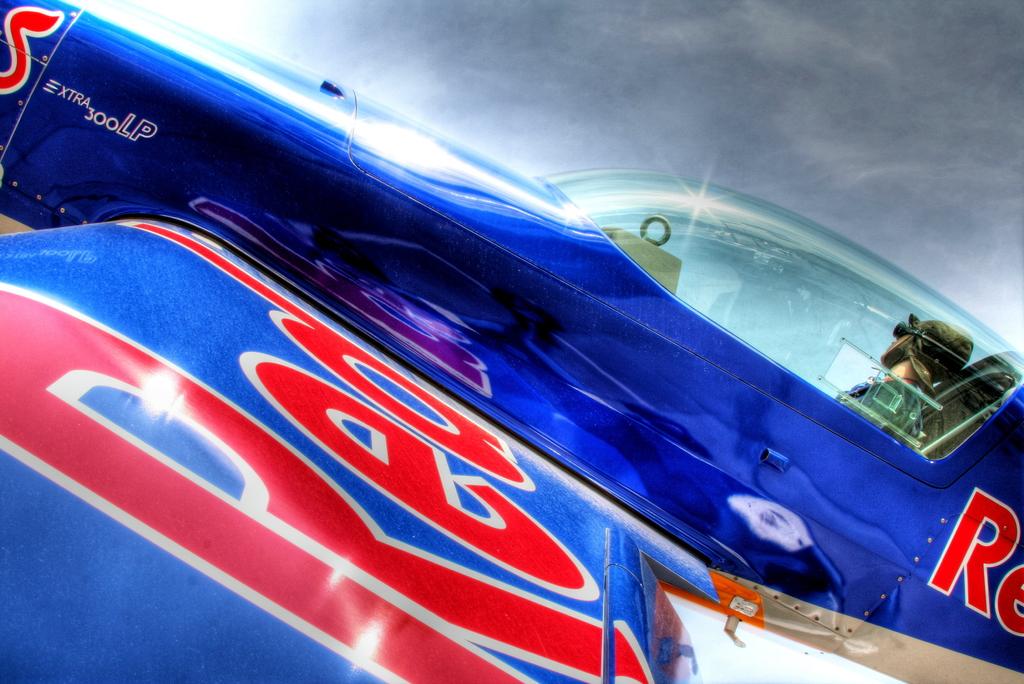What color is written on the wing?
Ensure brevity in your answer.  Red. 